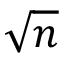<formula> <loc_0><loc_0><loc_500><loc_500>\sqrt { n }</formula> 